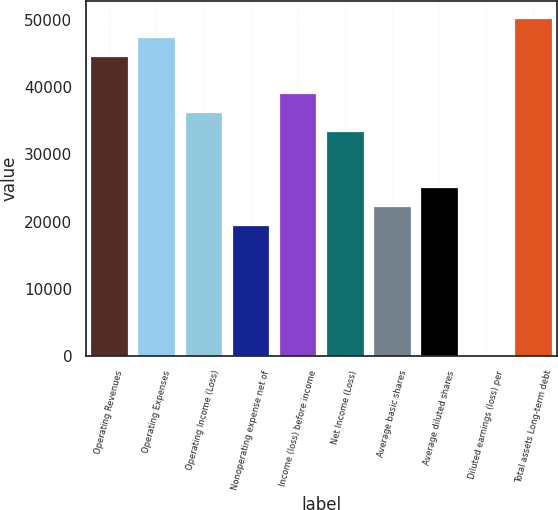Convert chart to OTSL. <chart><loc_0><loc_0><loc_500><loc_500><bar_chart><fcel>Operating Revenues<fcel>Operating Expenses<fcel>Operating Income (Loss)<fcel>Nonoperating expense net of<fcel>Income (loss) before income<fcel>Net Income (Loss)<fcel>Average basic shares<fcel>Average diluted shares<fcel>Diluted earnings (loss) per<fcel>Total assets Long-term debt<nl><fcel>44651.6<fcel>47442.2<fcel>36279.8<fcel>19536.1<fcel>39070.4<fcel>33489.2<fcel>22326.8<fcel>25117.4<fcel>1.87<fcel>50232.8<nl></chart> 